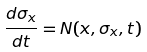Convert formula to latex. <formula><loc_0><loc_0><loc_500><loc_500>\frac { d \sigma _ { x } } { d t } = N ( x , \sigma _ { x } , t )</formula> 